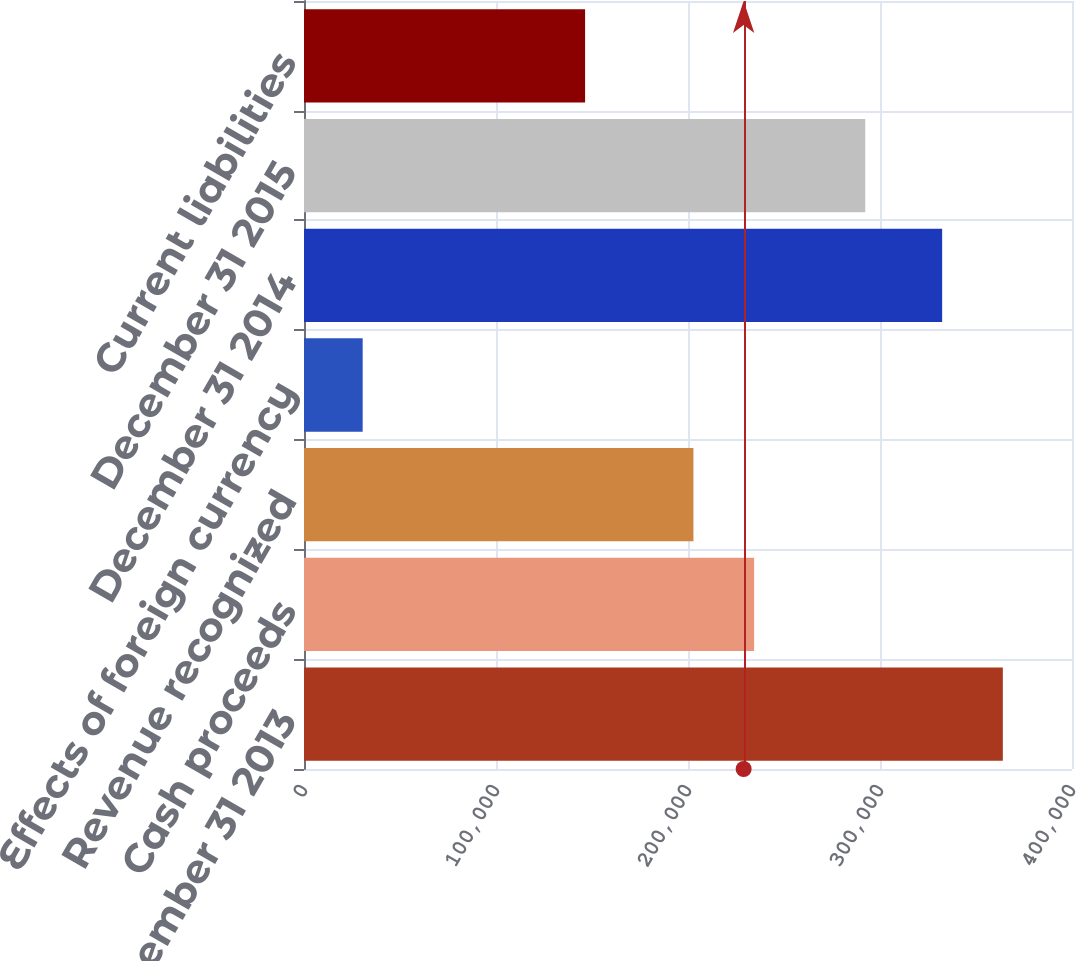Convert chart. <chart><loc_0><loc_0><loc_500><loc_500><bar_chart><fcel>December 31 2013<fcel>Cash proceeds<fcel>Revenue recognized<fcel>Effects of foreign currency<fcel>December 31 2014<fcel>December 31 2015<fcel>Current liabilities<nl><fcel>363975<fcel>234435<fcel>202828<fcel>30559<fcel>332368<fcel>292312<fcel>146402<nl></chart> 